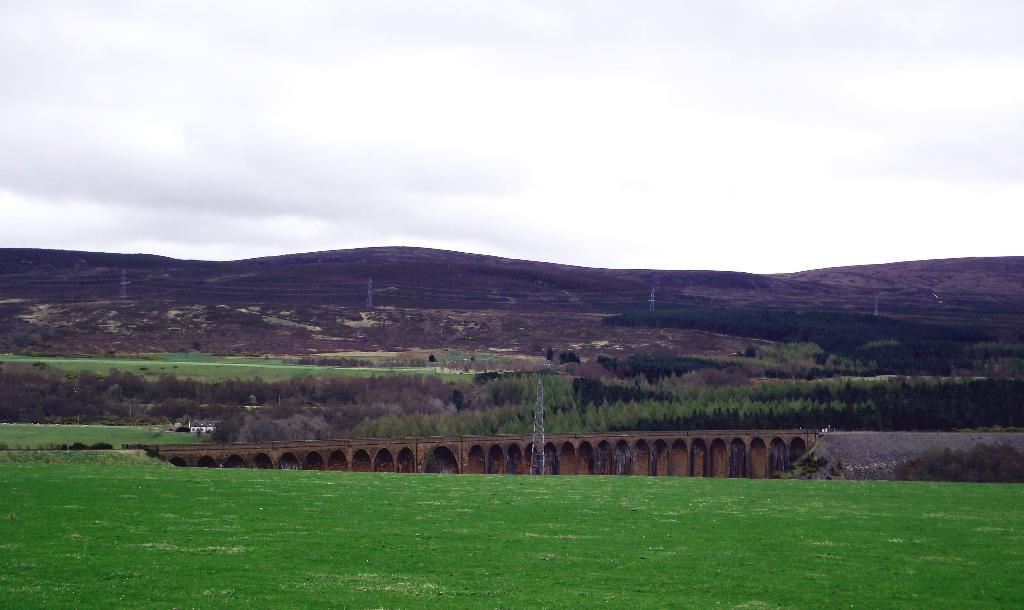What type of structures can be seen in the image? There are electricity towers in the image. What type of natural environment is visible in the image? There is grass, trees, hills, and the sky visible in the image. What type of man-made structure can be seen in the image? There is a bridge in the image. What else can be seen in the image besides the structures and natural environment? There are wires in the image. What is the condition of the sky in the image? The sky is visible in the image, and there are clouds present. What team is teaching the nation about electricity in the image? There is no team or nation present in the image; it simply shows electricity towers, grass, trees, a bridge, wires, hills, and the sky with clouds. 